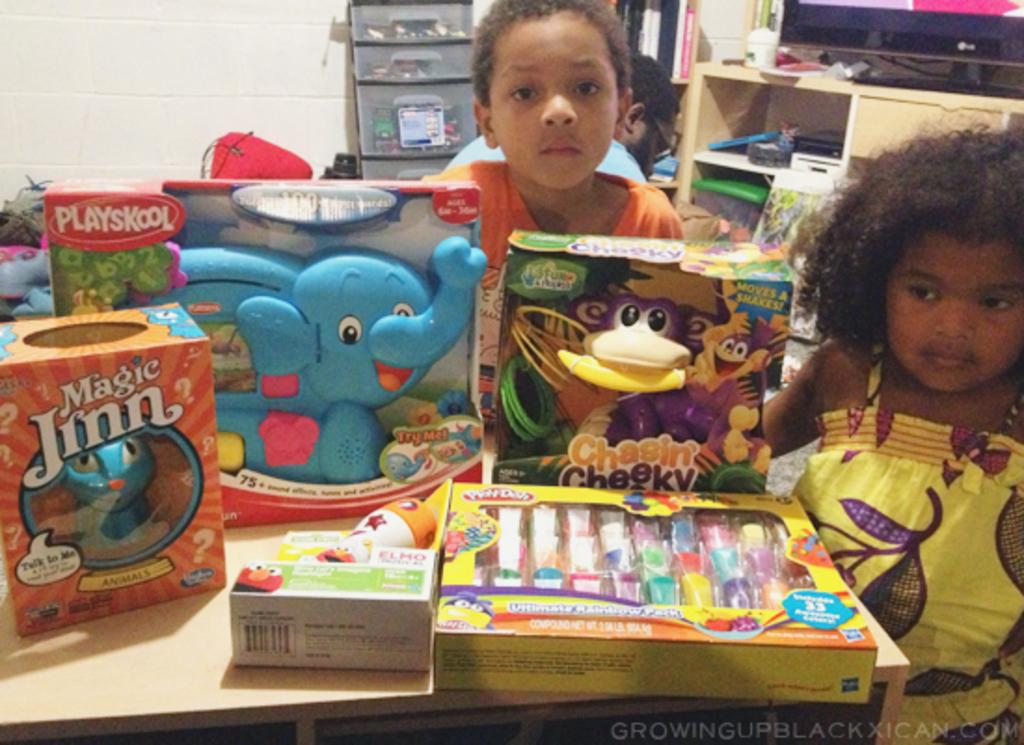What is the color of the wall in the image? The wall in the image is white. How many people are present in the image? There are three people in the image. What object can be seen in the image besides the people? There is a table in the image. What is on top of the table? There are boxes on the table. What type of club is the chicken holding in the image? There is no club or chicken present in the image. 